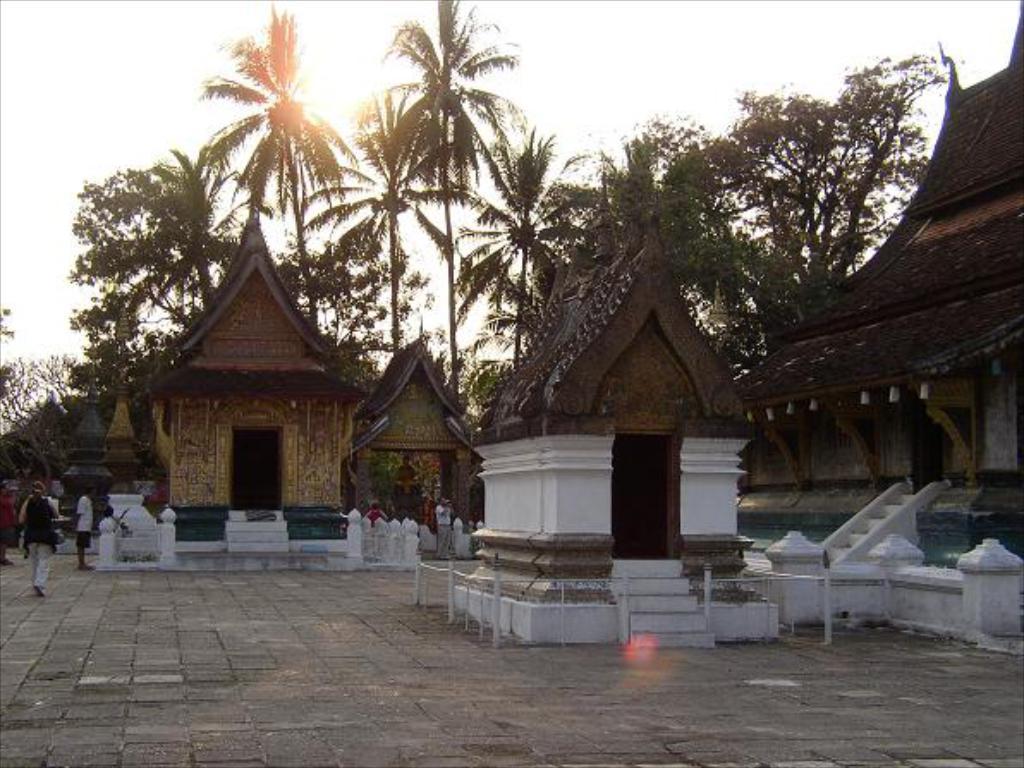Please provide a concise description of this image. In this image there are temples. People are standing on the floor. Left side there is a person walking on the floor. Background there are trees. Top of the image there is sky, having a son. 